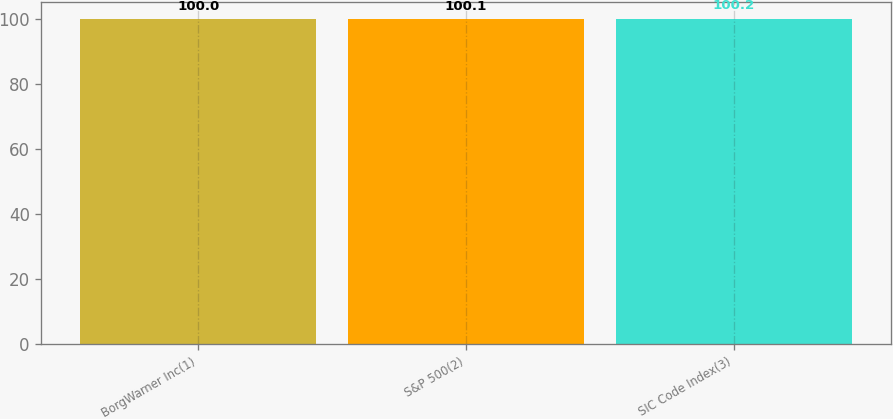Convert chart. <chart><loc_0><loc_0><loc_500><loc_500><bar_chart><fcel>BorgWarner Inc(1)<fcel>S&P 500(2)<fcel>SIC Code Index(3)<nl><fcel>100<fcel>100.1<fcel>100.2<nl></chart> 